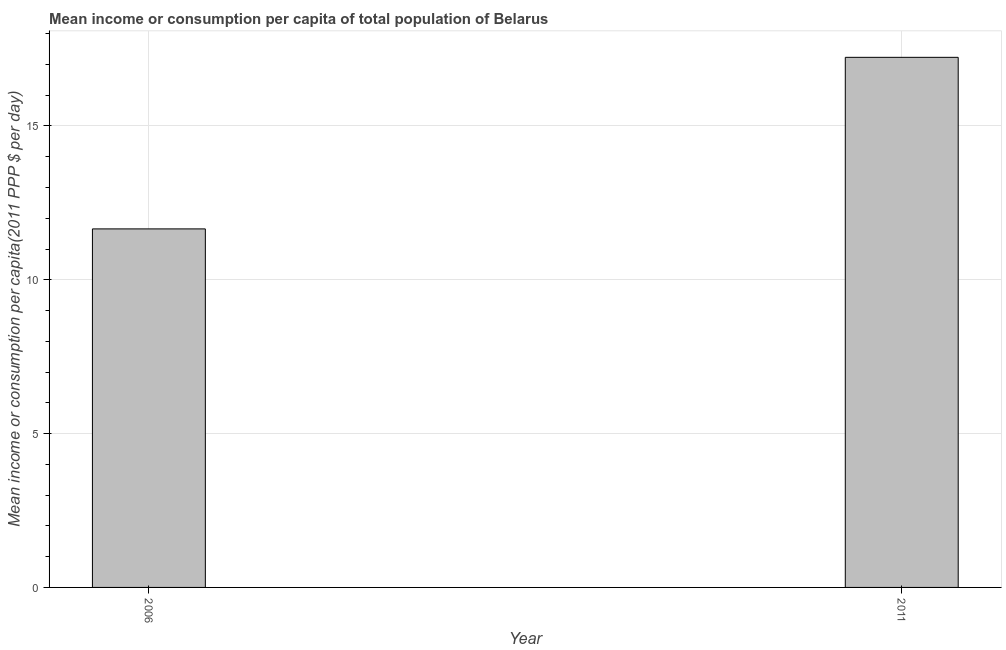Does the graph contain grids?
Give a very brief answer. Yes. What is the title of the graph?
Offer a terse response. Mean income or consumption per capita of total population of Belarus. What is the label or title of the Y-axis?
Your answer should be compact. Mean income or consumption per capita(2011 PPP $ per day). What is the mean income or consumption in 2006?
Provide a short and direct response. 11.65. Across all years, what is the maximum mean income or consumption?
Make the answer very short. 17.23. Across all years, what is the minimum mean income or consumption?
Provide a short and direct response. 11.65. In which year was the mean income or consumption minimum?
Offer a very short reply. 2006. What is the sum of the mean income or consumption?
Your answer should be very brief. 28.88. What is the difference between the mean income or consumption in 2006 and 2011?
Ensure brevity in your answer.  -5.58. What is the average mean income or consumption per year?
Provide a short and direct response. 14.44. What is the median mean income or consumption?
Keep it short and to the point. 14.44. In how many years, is the mean income or consumption greater than 3 $?
Keep it short and to the point. 2. What is the ratio of the mean income or consumption in 2006 to that in 2011?
Offer a very short reply. 0.68. How many bars are there?
Your answer should be compact. 2. What is the Mean income or consumption per capita(2011 PPP $ per day) in 2006?
Give a very brief answer. 11.65. What is the Mean income or consumption per capita(2011 PPP $ per day) in 2011?
Give a very brief answer. 17.23. What is the difference between the Mean income or consumption per capita(2011 PPP $ per day) in 2006 and 2011?
Your response must be concise. -5.58. What is the ratio of the Mean income or consumption per capita(2011 PPP $ per day) in 2006 to that in 2011?
Make the answer very short. 0.68. 